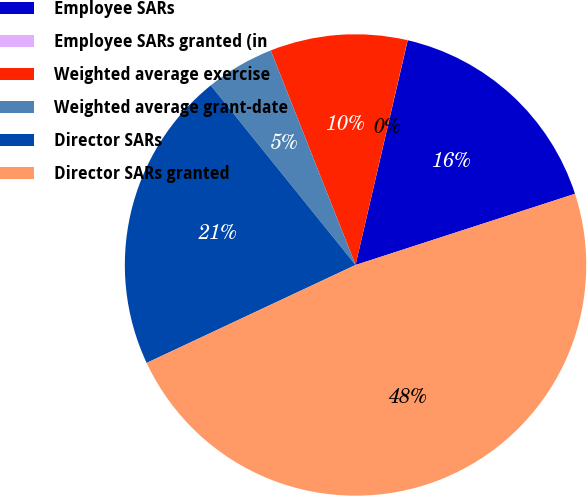<chart> <loc_0><loc_0><loc_500><loc_500><pie_chart><fcel>Employee SARs<fcel>Employee SARs granted (in<fcel>Weighted average exercise<fcel>Weighted average grant-date<fcel>Director SARs<fcel>Director SARs granted<nl><fcel>16.38%<fcel>0.01%<fcel>9.61%<fcel>4.81%<fcel>21.18%<fcel>48.02%<nl></chart> 